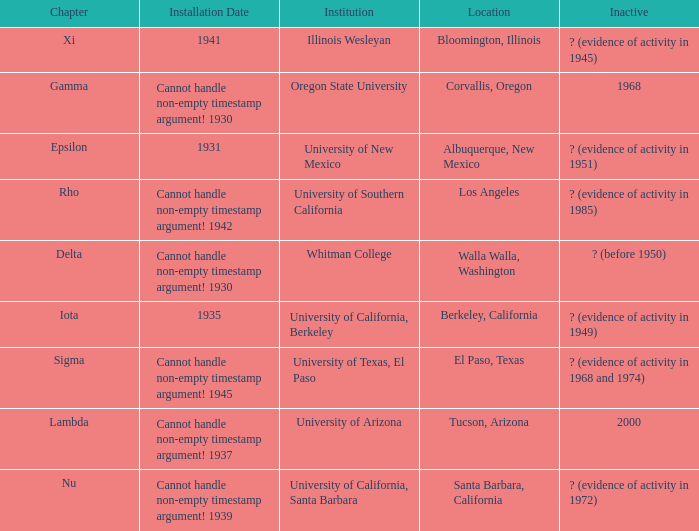What does the inactive state for University of Texas, El Paso?  ? (evidence of activity in 1968 and 1974). 